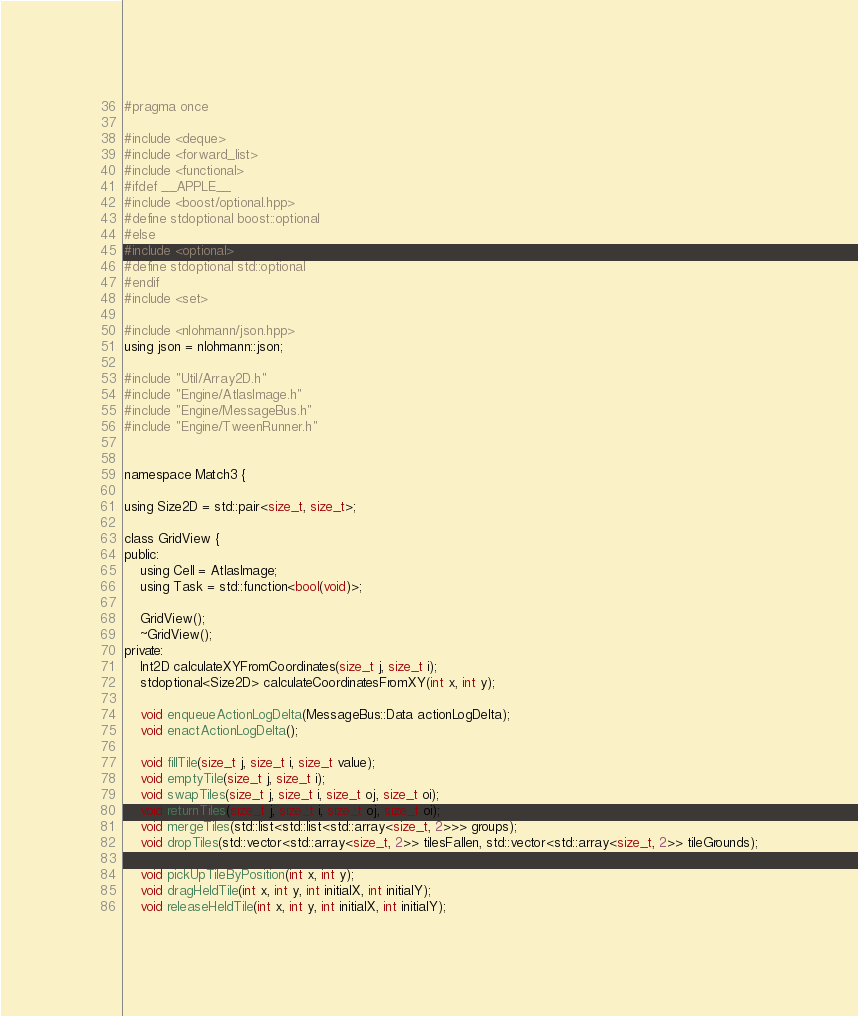Convert code to text. <code><loc_0><loc_0><loc_500><loc_500><_C_>#pragma once

#include <deque>
#include <forward_list>
#include <functional>
#ifdef __APPLE__
#include <boost/optional.hpp>
#define stdoptional boost::optional
#else
#include <optional>
#define stdoptional std::optional
#endif
#include <set>

#include <nlohmann/json.hpp>
using json = nlohmann::json;

#include "Util/Array2D.h"
#include "Engine/AtlasImage.h"
#include "Engine/MessageBus.h"
#include "Engine/TweenRunner.h"


namespace Match3 {

using Size2D = std::pair<size_t, size_t>;

class GridView {
public:
    using Cell = AtlasImage;
    using Task = std::function<bool(void)>;

    GridView();
    ~GridView();
private:
    Int2D calculateXYFromCoordinates(size_t j, size_t i);
    stdoptional<Size2D> calculateCoordinatesFromXY(int x, int y);

    void enqueueActionLogDelta(MessageBus::Data actionLogDelta);
    void enactActionLogDelta();

    void fillTile(size_t j, size_t i, size_t value);
    void emptyTile(size_t j, size_t i);
    void swapTiles(size_t j, size_t i, size_t oj, size_t oi);
    void returnTiles(size_t j, size_t i, size_t oj, size_t oi);
    void mergeTiles(std::list<std::list<std::array<size_t, 2>>> groups);
    void dropTiles(std::vector<std::array<size_t, 2>> tilesFallen, std::vector<std::array<size_t, 2>> tileGrounds);

    void pickUpTileByPosition(int x, int y);
    void dragHeldTile(int x, int y, int initialX, int initialY);
    void releaseHeldTile(int x, int y, int initialX, int initialY);
</code> 